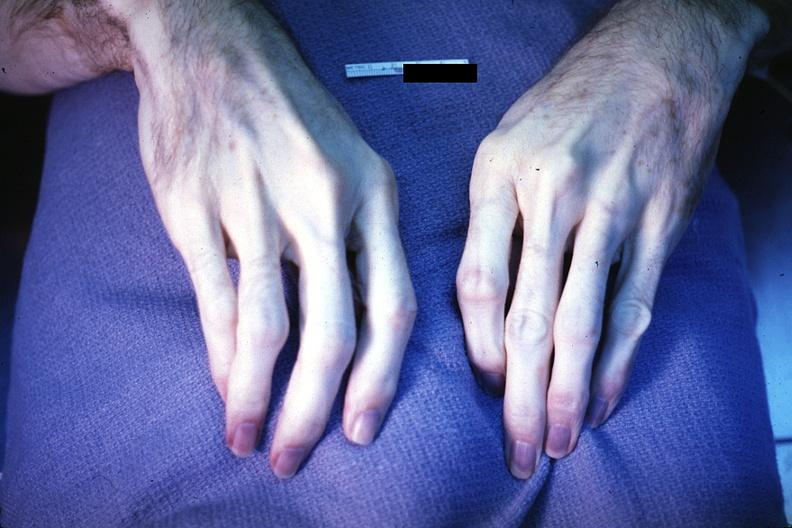what is present?
Answer the question using a single word or phrase. Hand 